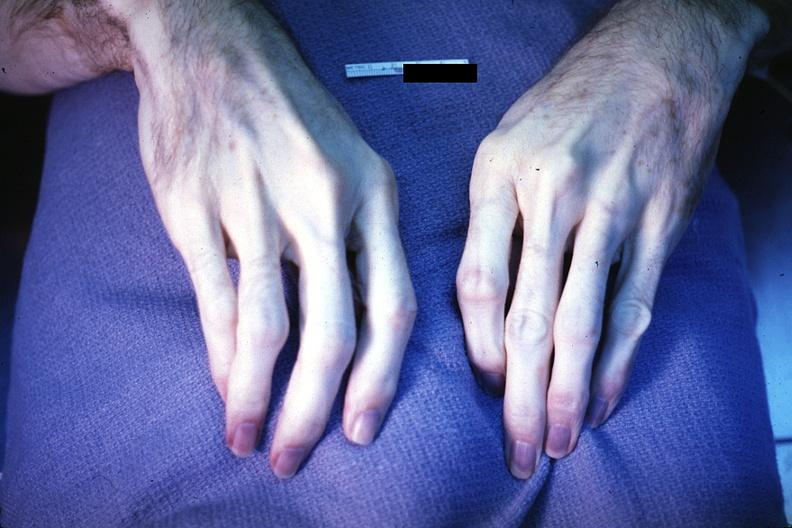what is present?
Answer the question using a single word or phrase. Hand 